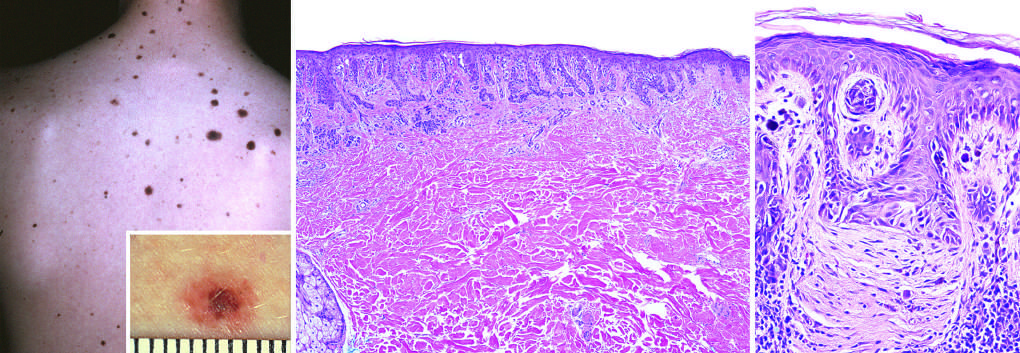does the former correspond to the raised, more pigmented central zone seen in the figure inset?
Answer the question using a single word or phrase. Yes 